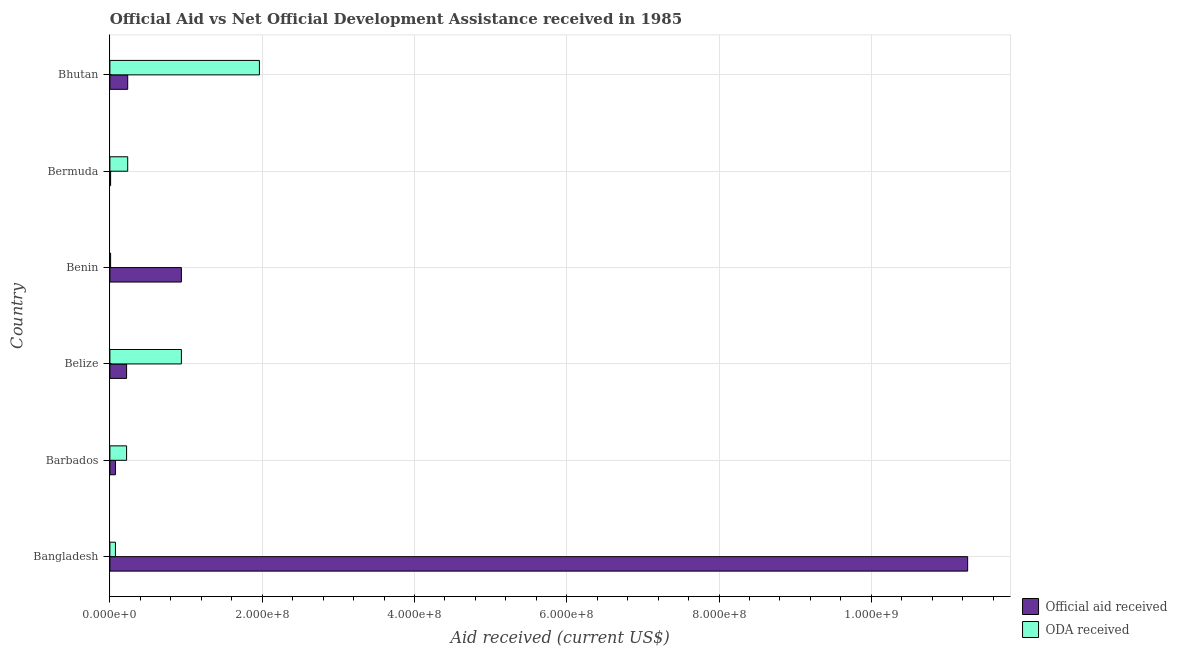How many different coloured bars are there?
Your response must be concise. 2. How many groups of bars are there?
Ensure brevity in your answer.  6. Are the number of bars per tick equal to the number of legend labels?
Give a very brief answer. Yes. How many bars are there on the 5th tick from the top?
Ensure brevity in your answer.  2. What is the label of the 5th group of bars from the top?
Provide a short and direct response. Barbados. In how many cases, is the number of bars for a given country not equal to the number of legend labels?
Your answer should be very brief. 0. What is the official aid received in Barbados?
Offer a very short reply. 7.29e+06. Across all countries, what is the maximum official aid received?
Provide a short and direct response. 1.13e+09. Across all countries, what is the minimum oda received?
Your answer should be compact. 9.40e+05. In which country was the official aid received maximum?
Your response must be concise. Bangladesh. In which country was the official aid received minimum?
Provide a succinct answer. Bermuda. What is the total official aid received in the graph?
Keep it short and to the point. 1.27e+09. What is the difference between the oda received in Benin and that in Bermuda?
Offer a terse response. -2.24e+07. What is the difference between the oda received in Bhutan and the official aid received in Benin?
Offer a terse response. 1.02e+08. What is the average official aid received per country?
Ensure brevity in your answer.  2.12e+08. What is the difference between the oda received and official aid received in Barbados?
Make the answer very short. 1.46e+07. In how many countries, is the official aid received greater than 600000000 US$?
Keep it short and to the point. 1. What is the ratio of the official aid received in Barbados to that in Bermuda?
Provide a succinct answer. 7.75. Is the difference between the oda received in Benin and Bhutan greater than the difference between the official aid received in Benin and Bhutan?
Give a very brief answer. No. What is the difference between the highest and the second highest official aid received?
Ensure brevity in your answer.  1.03e+09. What is the difference between the highest and the lowest official aid received?
Provide a succinct answer. 1.13e+09. In how many countries, is the oda received greater than the average oda received taken over all countries?
Offer a very short reply. 2. What does the 2nd bar from the top in Bangladesh represents?
Provide a short and direct response. Official aid received. What does the 2nd bar from the bottom in Belize represents?
Provide a short and direct response. ODA received. Does the graph contain grids?
Offer a very short reply. Yes. Where does the legend appear in the graph?
Offer a terse response. Bottom right. How many legend labels are there?
Your response must be concise. 2. How are the legend labels stacked?
Your answer should be very brief. Vertical. What is the title of the graph?
Your answer should be compact. Official Aid vs Net Official Development Assistance received in 1985 . Does "Time to import" appear as one of the legend labels in the graph?
Offer a terse response. No. What is the label or title of the X-axis?
Offer a very short reply. Aid received (current US$). What is the label or title of the Y-axis?
Give a very brief answer. Country. What is the Aid received (current US$) in Official aid received in Bangladesh?
Your response must be concise. 1.13e+09. What is the Aid received (current US$) of ODA received in Bangladesh?
Offer a terse response. 7.29e+06. What is the Aid received (current US$) of Official aid received in Barbados?
Your response must be concise. 7.29e+06. What is the Aid received (current US$) of ODA received in Barbados?
Keep it short and to the point. 2.19e+07. What is the Aid received (current US$) in Official aid received in Belize?
Offer a very short reply. 2.19e+07. What is the Aid received (current US$) in ODA received in Belize?
Provide a short and direct response. 9.39e+07. What is the Aid received (current US$) of Official aid received in Benin?
Provide a succinct answer. 9.39e+07. What is the Aid received (current US$) of ODA received in Benin?
Offer a very short reply. 9.40e+05. What is the Aid received (current US$) of Official aid received in Bermuda?
Provide a succinct answer. 9.40e+05. What is the Aid received (current US$) in ODA received in Bermuda?
Offer a terse response. 2.34e+07. What is the Aid received (current US$) of Official aid received in Bhutan?
Give a very brief answer. 2.34e+07. What is the Aid received (current US$) in ODA received in Bhutan?
Provide a short and direct response. 1.96e+08. Across all countries, what is the maximum Aid received (current US$) in Official aid received?
Ensure brevity in your answer.  1.13e+09. Across all countries, what is the maximum Aid received (current US$) of ODA received?
Ensure brevity in your answer.  1.96e+08. Across all countries, what is the minimum Aid received (current US$) of Official aid received?
Give a very brief answer. 9.40e+05. Across all countries, what is the minimum Aid received (current US$) in ODA received?
Make the answer very short. 9.40e+05. What is the total Aid received (current US$) of Official aid received in the graph?
Offer a very short reply. 1.27e+09. What is the total Aid received (current US$) of ODA received in the graph?
Your response must be concise. 3.44e+08. What is the difference between the Aid received (current US$) in Official aid received in Bangladesh and that in Barbados?
Your response must be concise. 1.12e+09. What is the difference between the Aid received (current US$) of ODA received in Bangladesh and that in Barbados?
Offer a terse response. -1.46e+07. What is the difference between the Aid received (current US$) of Official aid received in Bangladesh and that in Belize?
Provide a short and direct response. 1.10e+09. What is the difference between the Aid received (current US$) in ODA received in Bangladesh and that in Belize?
Keep it short and to the point. -8.66e+07. What is the difference between the Aid received (current US$) of Official aid received in Bangladesh and that in Benin?
Keep it short and to the point. 1.03e+09. What is the difference between the Aid received (current US$) of ODA received in Bangladesh and that in Benin?
Ensure brevity in your answer.  6.35e+06. What is the difference between the Aid received (current US$) of Official aid received in Bangladesh and that in Bermuda?
Provide a short and direct response. 1.13e+09. What is the difference between the Aid received (current US$) in ODA received in Bangladesh and that in Bermuda?
Your response must be concise. -1.61e+07. What is the difference between the Aid received (current US$) in Official aid received in Bangladesh and that in Bhutan?
Your response must be concise. 1.10e+09. What is the difference between the Aid received (current US$) in ODA received in Bangladesh and that in Bhutan?
Your answer should be compact. -1.89e+08. What is the difference between the Aid received (current US$) in Official aid received in Barbados and that in Belize?
Offer a very short reply. -1.46e+07. What is the difference between the Aid received (current US$) in ODA received in Barbados and that in Belize?
Your answer should be compact. -7.20e+07. What is the difference between the Aid received (current US$) of Official aid received in Barbados and that in Benin?
Make the answer very short. -8.66e+07. What is the difference between the Aid received (current US$) of ODA received in Barbados and that in Benin?
Provide a succinct answer. 2.10e+07. What is the difference between the Aid received (current US$) in Official aid received in Barbados and that in Bermuda?
Provide a succinct answer. 6.35e+06. What is the difference between the Aid received (current US$) in ODA received in Barbados and that in Bermuda?
Provide a short and direct response. -1.46e+06. What is the difference between the Aid received (current US$) of Official aid received in Barbados and that in Bhutan?
Provide a succinct answer. -1.61e+07. What is the difference between the Aid received (current US$) in ODA received in Barbados and that in Bhutan?
Make the answer very short. -1.74e+08. What is the difference between the Aid received (current US$) of Official aid received in Belize and that in Benin?
Offer a very short reply. -7.20e+07. What is the difference between the Aid received (current US$) of ODA received in Belize and that in Benin?
Offer a very short reply. 9.30e+07. What is the difference between the Aid received (current US$) in Official aid received in Belize and that in Bermuda?
Offer a terse response. 2.10e+07. What is the difference between the Aid received (current US$) in ODA received in Belize and that in Bermuda?
Ensure brevity in your answer.  7.05e+07. What is the difference between the Aid received (current US$) in Official aid received in Belize and that in Bhutan?
Make the answer very short. -1.46e+06. What is the difference between the Aid received (current US$) of ODA received in Belize and that in Bhutan?
Provide a short and direct response. -1.02e+08. What is the difference between the Aid received (current US$) of Official aid received in Benin and that in Bermuda?
Ensure brevity in your answer.  9.30e+07. What is the difference between the Aid received (current US$) of ODA received in Benin and that in Bermuda?
Offer a terse response. -2.24e+07. What is the difference between the Aid received (current US$) in Official aid received in Benin and that in Bhutan?
Provide a succinct answer. 7.05e+07. What is the difference between the Aid received (current US$) in ODA received in Benin and that in Bhutan?
Your response must be concise. -1.95e+08. What is the difference between the Aid received (current US$) in Official aid received in Bermuda and that in Bhutan?
Give a very brief answer. -2.24e+07. What is the difference between the Aid received (current US$) of ODA received in Bermuda and that in Bhutan?
Ensure brevity in your answer.  -1.73e+08. What is the difference between the Aid received (current US$) of Official aid received in Bangladesh and the Aid received (current US$) of ODA received in Barbados?
Provide a short and direct response. 1.10e+09. What is the difference between the Aid received (current US$) of Official aid received in Bangladesh and the Aid received (current US$) of ODA received in Belize?
Provide a succinct answer. 1.03e+09. What is the difference between the Aid received (current US$) in Official aid received in Bangladesh and the Aid received (current US$) in ODA received in Benin?
Give a very brief answer. 1.13e+09. What is the difference between the Aid received (current US$) of Official aid received in Bangladesh and the Aid received (current US$) of ODA received in Bermuda?
Provide a succinct answer. 1.10e+09. What is the difference between the Aid received (current US$) of Official aid received in Bangladesh and the Aid received (current US$) of ODA received in Bhutan?
Provide a succinct answer. 9.30e+08. What is the difference between the Aid received (current US$) of Official aid received in Barbados and the Aid received (current US$) of ODA received in Belize?
Your answer should be compact. -8.66e+07. What is the difference between the Aid received (current US$) in Official aid received in Barbados and the Aid received (current US$) in ODA received in Benin?
Your answer should be compact. 6.35e+06. What is the difference between the Aid received (current US$) of Official aid received in Barbados and the Aid received (current US$) of ODA received in Bermuda?
Make the answer very short. -1.61e+07. What is the difference between the Aid received (current US$) of Official aid received in Barbados and the Aid received (current US$) of ODA received in Bhutan?
Your response must be concise. -1.89e+08. What is the difference between the Aid received (current US$) of Official aid received in Belize and the Aid received (current US$) of ODA received in Benin?
Make the answer very short. 2.10e+07. What is the difference between the Aid received (current US$) in Official aid received in Belize and the Aid received (current US$) in ODA received in Bermuda?
Make the answer very short. -1.46e+06. What is the difference between the Aid received (current US$) of Official aid received in Belize and the Aid received (current US$) of ODA received in Bhutan?
Offer a very short reply. -1.74e+08. What is the difference between the Aid received (current US$) in Official aid received in Benin and the Aid received (current US$) in ODA received in Bermuda?
Your response must be concise. 7.05e+07. What is the difference between the Aid received (current US$) of Official aid received in Benin and the Aid received (current US$) of ODA received in Bhutan?
Ensure brevity in your answer.  -1.02e+08. What is the difference between the Aid received (current US$) in Official aid received in Bermuda and the Aid received (current US$) in ODA received in Bhutan?
Give a very brief answer. -1.95e+08. What is the average Aid received (current US$) in Official aid received per country?
Ensure brevity in your answer.  2.12e+08. What is the average Aid received (current US$) in ODA received per country?
Keep it short and to the point. 5.73e+07. What is the difference between the Aid received (current US$) in Official aid received and Aid received (current US$) in ODA received in Bangladesh?
Give a very brief answer. 1.12e+09. What is the difference between the Aid received (current US$) in Official aid received and Aid received (current US$) in ODA received in Barbados?
Offer a very short reply. -1.46e+07. What is the difference between the Aid received (current US$) of Official aid received and Aid received (current US$) of ODA received in Belize?
Your answer should be very brief. -7.20e+07. What is the difference between the Aid received (current US$) in Official aid received and Aid received (current US$) in ODA received in Benin?
Your response must be concise. 9.30e+07. What is the difference between the Aid received (current US$) in Official aid received and Aid received (current US$) in ODA received in Bermuda?
Your answer should be compact. -2.24e+07. What is the difference between the Aid received (current US$) of Official aid received and Aid received (current US$) of ODA received in Bhutan?
Offer a very short reply. -1.73e+08. What is the ratio of the Aid received (current US$) in Official aid received in Bangladesh to that in Barbados?
Provide a succinct answer. 154.53. What is the ratio of the Aid received (current US$) in ODA received in Bangladesh to that in Barbados?
Offer a very short reply. 0.33. What is the ratio of the Aid received (current US$) of Official aid received in Bangladesh to that in Belize?
Ensure brevity in your answer.  51.37. What is the ratio of the Aid received (current US$) of ODA received in Bangladesh to that in Belize?
Make the answer very short. 0.08. What is the ratio of the Aid received (current US$) of Official aid received in Bangladesh to that in Benin?
Offer a very short reply. 12. What is the ratio of the Aid received (current US$) of ODA received in Bangladesh to that in Benin?
Your response must be concise. 7.76. What is the ratio of the Aid received (current US$) in Official aid received in Bangladesh to that in Bermuda?
Your response must be concise. 1198.44. What is the ratio of the Aid received (current US$) in ODA received in Bangladesh to that in Bermuda?
Ensure brevity in your answer.  0.31. What is the ratio of the Aid received (current US$) of Official aid received in Bangladesh to that in Bhutan?
Your answer should be compact. 48.16. What is the ratio of the Aid received (current US$) of ODA received in Bangladesh to that in Bhutan?
Provide a succinct answer. 0.04. What is the ratio of the Aid received (current US$) in Official aid received in Barbados to that in Belize?
Your answer should be compact. 0.33. What is the ratio of the Aid received (current US$) of ODA received in Barbados to that in Belize?
Your answer should be compact. 0.23. What is the ratio of the Aid received (current US$) in Official aid received in Barbados to that in Benin?
Your answer should be very brief. 0.08. What is the ratio of the Aid received (current US$) of ODA received in Barbados to that in Benin?
Make the answer very short. 23.33. What is the ratio of the Aid received (current US$) in Official aid received in Barbados to that in Bermuda?
Your response must be concise. 7.76. What is the ratio of the Aid received (current US$) in ODA received in Barbados to that in Bermuda?
Ensure brevity in your answer.  0.94. What is the ratio of the Aid received (current US$) in Official aid received in Barbados to that in Bhutan?
Your response must be concise. 0.31. What is the ratio of the Aid received (current US$) of ODA received in Barbados to that in Bhutan?
Your answer should be compact. 0.11. What is the ratio of the Aid received (current US$) in Official aid received in Belize to that in Benin?
Give a very brief answer. 0.23. What is the ratio of the Aid received (current US$) in ODA received in Belize to that in Benin?
Your answer should be very brief. 99.9. What is the ratio of the Aid received (current US$) in Official aid received in Belize to that in Bermuda?
Offer a terse response. 23.33. What is the ratio of the Aid received (current US$) in ODA received in Belize to that in Bermuda?
Your answer should be compact. 4.01. What is the ratio of the Aid received (current US$) of Official aid received in Belize to that in Bhutan?
Provide a short and direct response. 0.94. What is the ratio of the Aid received (current US$) of ODA received in Belize to that in Bhutan?
Give a very brief answer. 0.48. What is the ratio of the Aid received (current US$) of Official aid received in Benin to that in Bermuda?
Provide a succinct answer. 99.9. What is the ratio of the Aid received (current US$) of ODA received in Benin to that in Bermuda?
Your response must be concise. 0.04. What is the ratio of the Aid received (current US$) in Official aid received in Benin to that in Bhutan?
Offer a very short reply. 4.01. What is the ratio of the Aid received (current US$) in ODA received in Benin to that in Bhutan?
Your answer should be very brief. 0. What is the ratio of the Aid received (current US$) of Official aid received in Bermuda to that in Bhutan?
Provide a short and direct response. 0.04. What is the ratio of the Aid received (current US$) in ODA received in Bermuda to that in Bhutan?
Your answer should be compact. 0.12. What is the difference between the highest and the second highest Aid received (current US$) of Official aid received?
Your answer should be compact. 1.03e+09. What is the difference between the highest and the second highest Aid received (current US$) of ODA received?
Offer a very short reply. 1.02e+08. What is the difference between the highest and the lowest Aid received (current US$) in Official aid received?
Offer a very short reply. 1.13e+09. What is the difference between the highest and the lowest Aid received (current US$) of ODA received?
Your answer should be compact. 1.95e+08. 